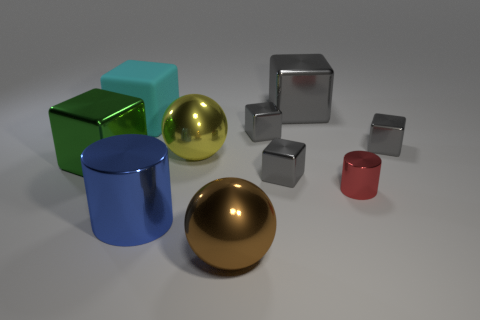There is a small red thing that is the same shape as the large blue object; what is it made of?
Your response must be concise. Metal. There is a shiny cylinder that is to the right of the big gray metal block; what number of large shiny objects are in front of it?
Your answer should be compact. 2. There is a thing that is in front of the tiny red metallic thing and behind the large brown sphere; what size is it?
Provide a succinct answer. Large. What material is the cube that is behind the cyan rubber thing?
Offer a terse response. Metal. Are there any gray things that have the same shape as the large blue thing?
Offer a terse response. No. How many big cyan matte things are the same shape as the small red thing?
Your answer should be compact. 0. Does the metal cube right of the red metallic cylinder have the same size as the shiny cube that is behind the cyan rubber thing?
Your response must be concise. No. There is a small gray metallic object that is in front of the large block that is in front of the large yellow sphere; what shape is it?
Your answer should be compact. Cube. Is the number of tiny blocks that are behind the big cyan rubber cube the same as the number of big brown spheres?
Provide a succinct answer. No. What is the material of the small gray block to the right of the big thing that is right of the large sphere in front of the large green metal block?
Offer a terse response. Metal. 